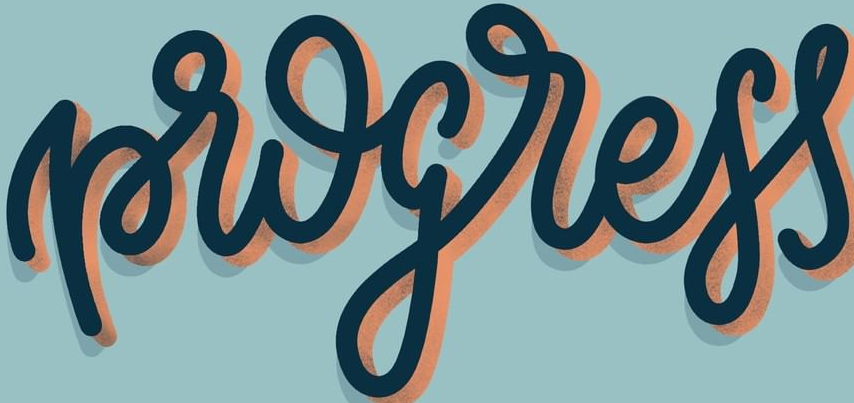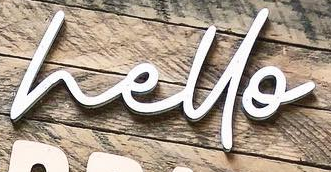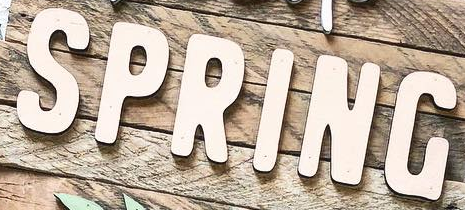Identify the words shown in these images in order, separated by a semicolon. progress; hello; SPRING 